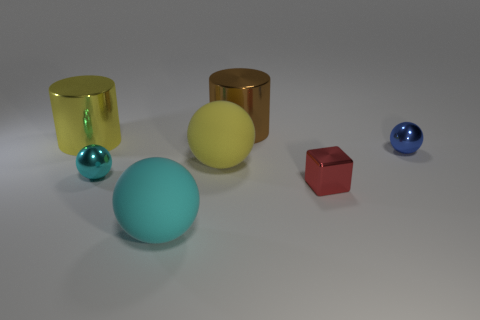Subtract all gray cylinders. Subtract all purple cubes. How many cylinders are left? 2 Subtract all purple spheres. How many blue cubes are left? 0 Add 2 small things. How many browns exist? 0 Subtract all tiny spheres. Subtract all small blue rubber cylinders. How many objects are left? 5 Add 6 small cyan shiny spheres. How many small cyan shiny spheres are left? 7 Add 6 red cubes. How many red cubes exist? 7 Add 2 blue objects. How many objects exist? 9 Subtract all brown cylinders. How many cylinders are left? 1 Subtract all big cyan spheres. How many spheres are left? 3 Subtract 0 gray cylinders. How many objects are left? 7 